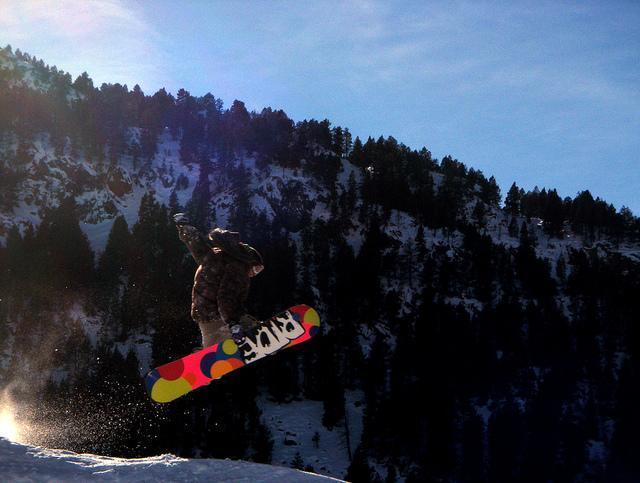How many snowboards are there?
Give a very brief answer. 1. 